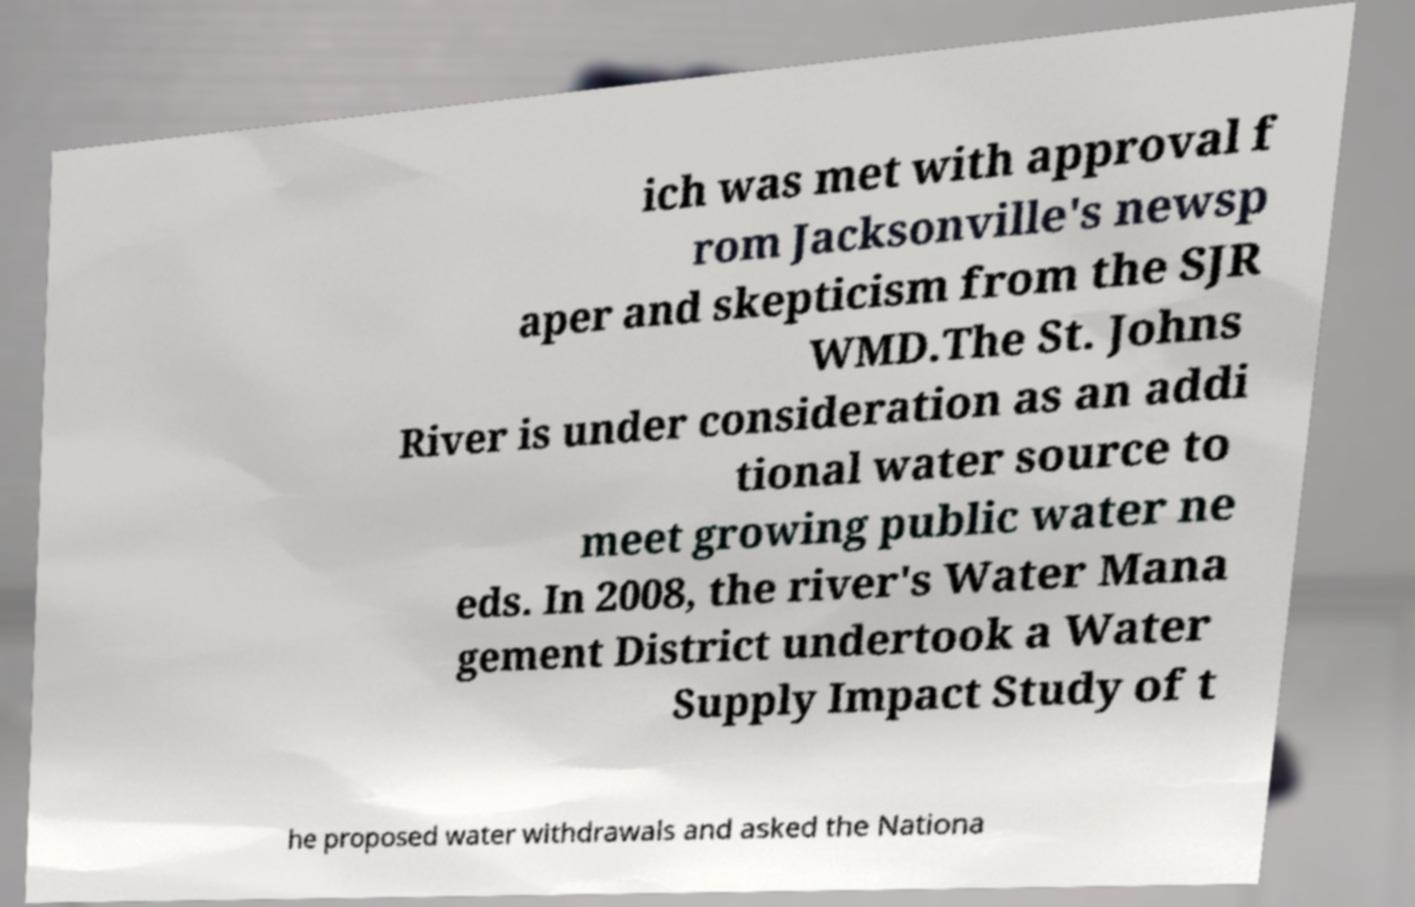Please read and relay the text visible in this image. What does it say? ich was met with approval f rom Jacksonville's newsp aper and skepticism from the SJR WMD.The St. Johns River is under consideration as an addi tional water source to meet growing public water ne eds. In 2008, the river's Water Mana gement District undertook a Water Supply Impact Study of t he proposed water withdrawals and asked the Nationa 